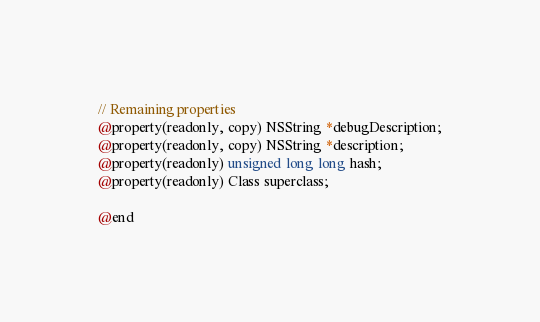<code> <loc_0><loc_0><loc_500><loc_500><_C_>
// Remaining properties
@property(readonly, copy) NSString *debugDescription;
@property(readonly, copy) NSString *description;
@property(readonly) unsigned long long hash;
@property(readonly) Class superclass;

@end

</code> 